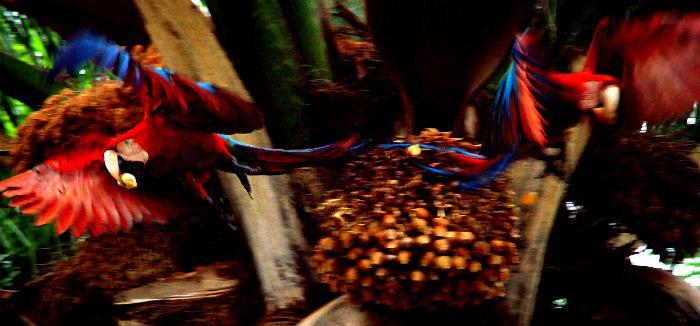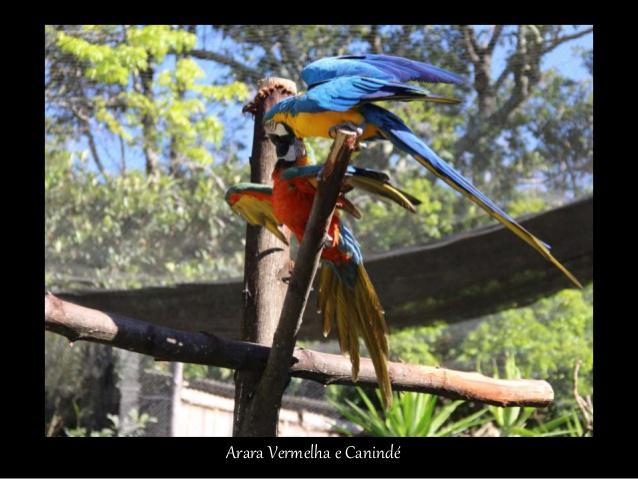The first image is the image on the left, the second image is the image on the right. Assess this claim about the two images: "One of the birds in the right image has its wings spread.". Correct or not? Answer yes or no. Yes. 